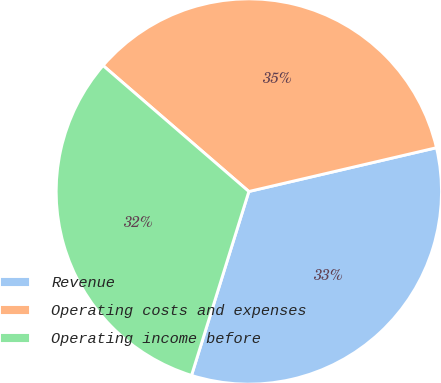Convert chart. <chart><loc_0><loc_0><loc_500><loc_500><pie_chart><fcel>Revenue<fcel>Operating costs and expenses<fcel>Operating income before<nl><fcel>33.46%<fcel>35.01%<fcel>31.53%<nl></chart> 